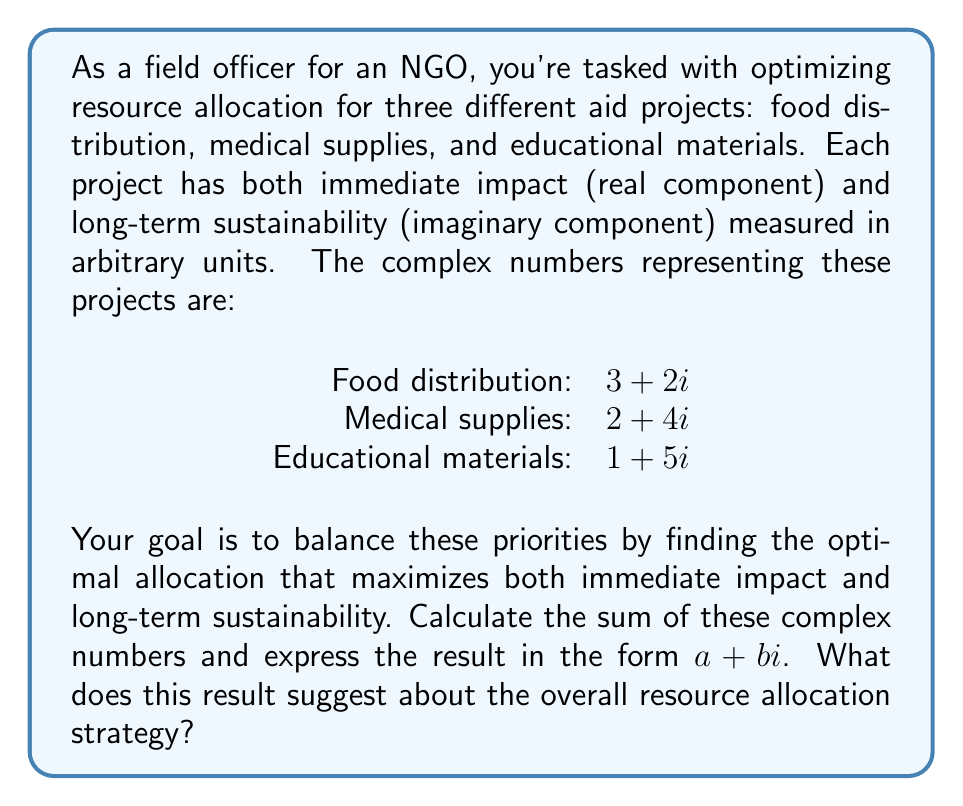Provide a solution to this math problem. To solve this problem, we need to add the complex numbers representing each project. Let's break it down step-by-step:

1) We have three complex numbers:
   Food distribution: $3 + 2i$
   Medical supplies: $2 + 4i$
   Educational materials: $1 + 5i$

2) To add complex numbers, we add the real parts and imaginary parts separately:

   $$(3 + 2i) + (2 + 4i) + (1 + 5i)$$

3) Grouping real and imaginary parts:

   $$(3 + 2 + 1) + (2i + 4i + 5i)$$

4) Simplifying:

   $$6 + 11i$$

5) Interpretation:
   - The real part (6) represents the total immediate impact across all projects.
   - The imaginary part (11) represents the total long-term sustainability across all projects.

This result suggests that the current allocation strategy places a higher emphasis on long-term sustainability (11) compared to immediate impact (6). As a field officer, this information can help you decide whether to adjust the allocation to balance short-term and long-term priorities better, or to maintain this focus on sustainability depending on the organization's goals and the specific needs of the communities you serve.
Answer: $6 + 11i$ 